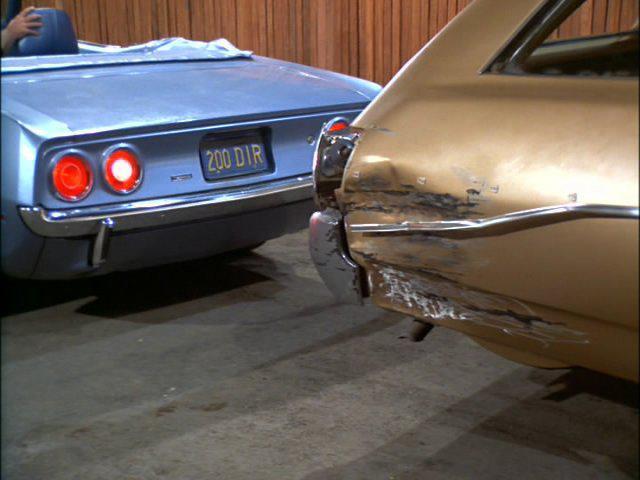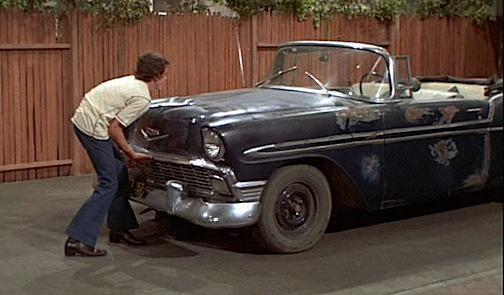The first image is the image on the left, the second image is the image on the right. For the images shown, is this caption "All of the cars in the images are sky blue." true? Answer yes or no. No. The first image is the image on the left, the second image is the image on the right. For the images displayed, is the sentence "Each image shows a person behind the wheel of a convertible." factually correct? Answer yes or no. No. 